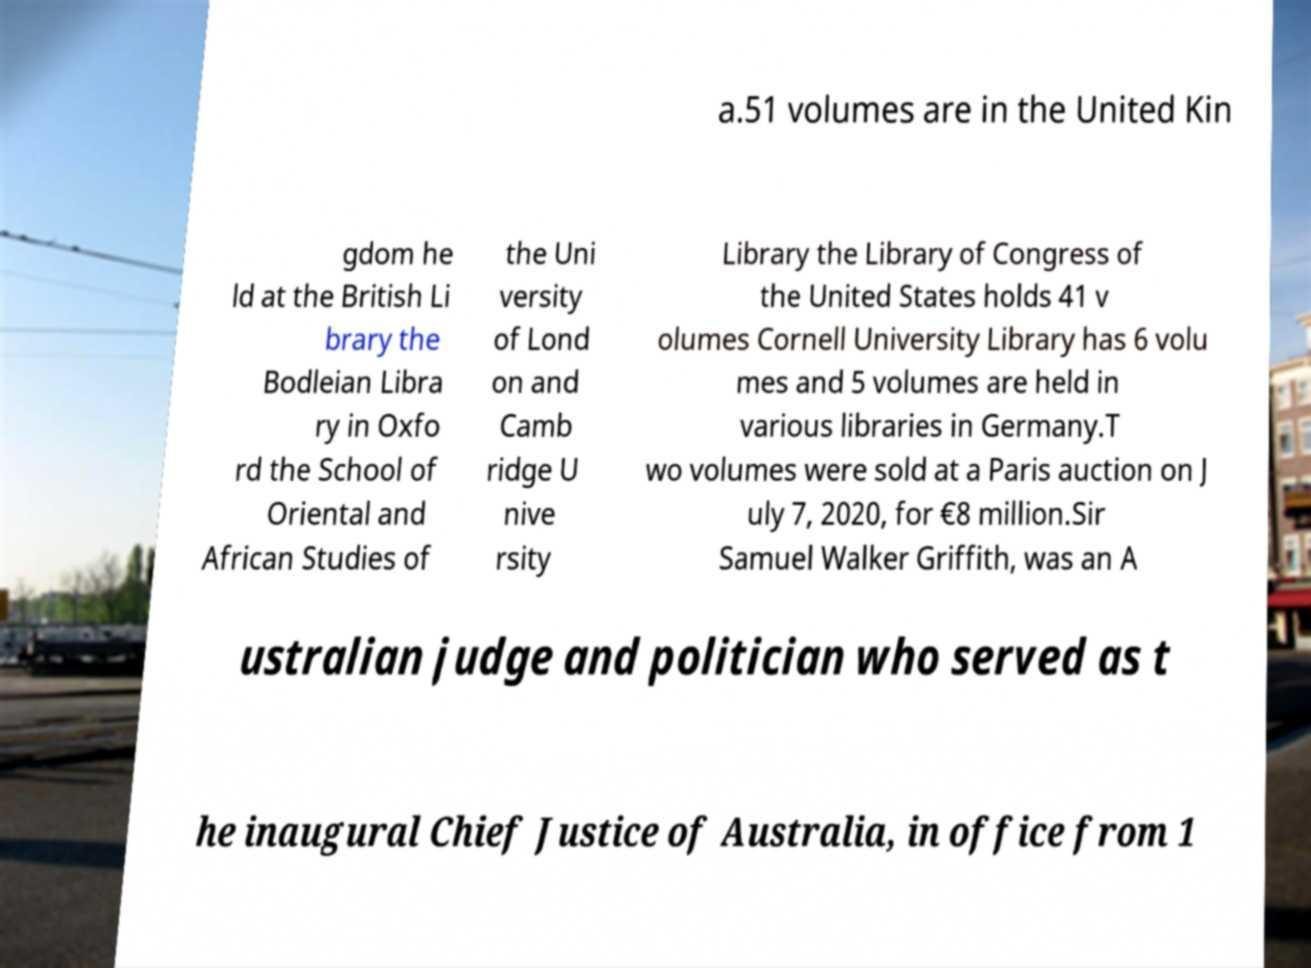I need the written content from this picture converted into text. Can you do that? a.51 volumes are in the United Kin gdom he ld at the British Li brary the Bodleian Libra ry in Oxfo rd the School of Oriental and African Studies of the Uni versity of Lond on and Camb ridge U nive rsity Library the Library of Congress of the United States holds 41 v olumes Cornell University Library has 6 volu mes and 5 volumes are held in various libraries in Germany.T wo volumes were sold at a Paris auction on J uly 7, 2020, for €8 million.Sir Samuel Walker Griffith, was an A ustralian judge and politician who served as t he inaugural Chief Justice of Australia, in office from 1 